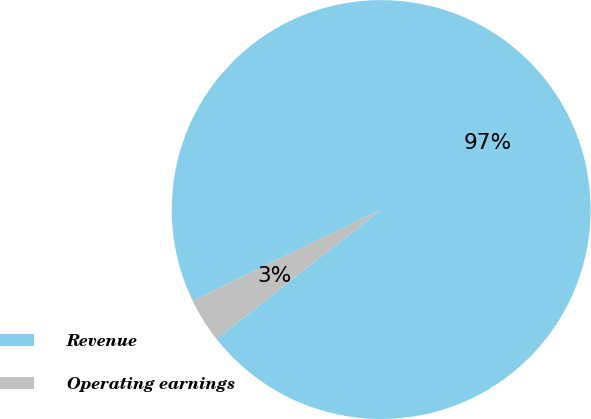<chart> <loc_0><loc_0><loc_500><loc_500><pie_chart><fcel>Revenue<fcel>Operating earnings<nl><fcel>96.56%<fcel>3.44%<nl></chart> 